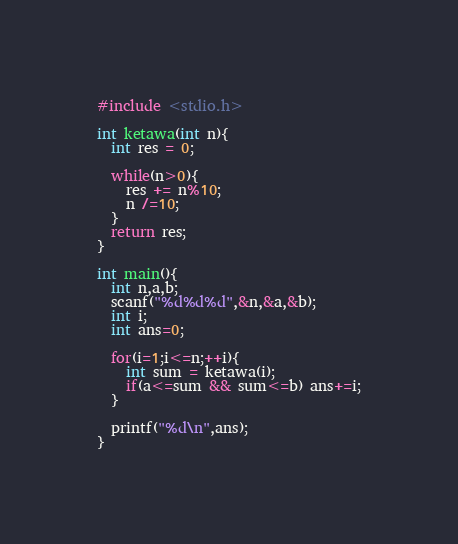<code> <loc_0><loc_0><loc_500><loc_500><_C_>#include <stdio.h>

int ketawa(int n){
  int res = 0;
  
  while(n>0){
    res += n%10;
    n /=10;
  }
  return res;
}

int main(){
  int n,a,b;
  scanf("%d%d%d",&n,&a,&b);
  int i;
  int ans=0;
  
  for(i=1;i<=n;++i){
    int sum = ketawa(i);
    if(a<=sum && sum<=b) ans+=i;
  }
  
  printf("%d\n",ans);
}
</code> 